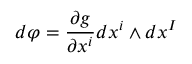Convert formula to latex. <formula><loc_0><loc_0><loc_500><loc_500>d { \varphi } = { \frac { \partial g } { \partial x ^ { i } } } d x ^ { i } \wedge d x ^ { I }</formula> 